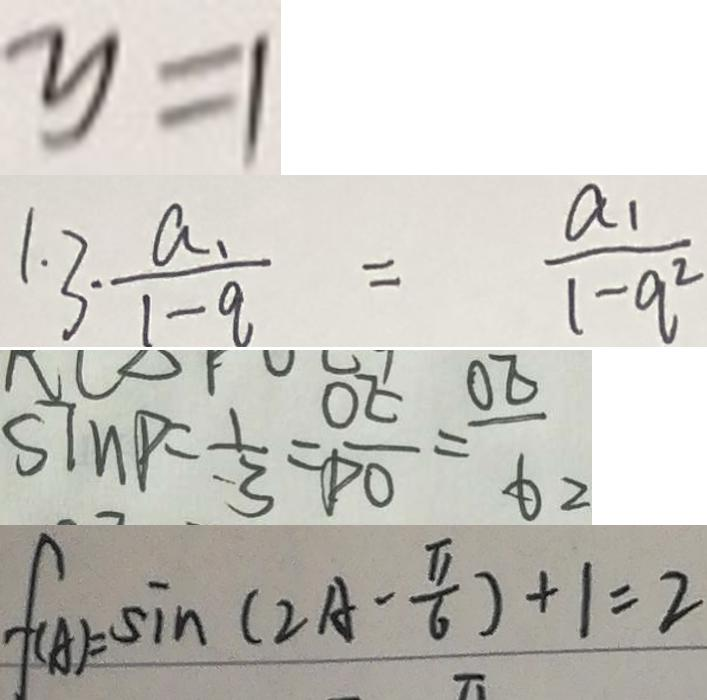<formula> <loc_0><loc_0><loc_500><loc_500>y = 1 
 1 . 3 \cdot \frac { a _ { 1 } } { 1 - q } = \frac { a _ { 1 } } { 1 - q ^ { 2 } } 
 S \ln P = \frac { 1 } { 3 } = \frac { O E } { P O } = \frac { O E } { 6 2 } 
 f ( A ) = \sin ( 2 A - \frac { \pi } { 6 } ) + 1 = 2</formula> 